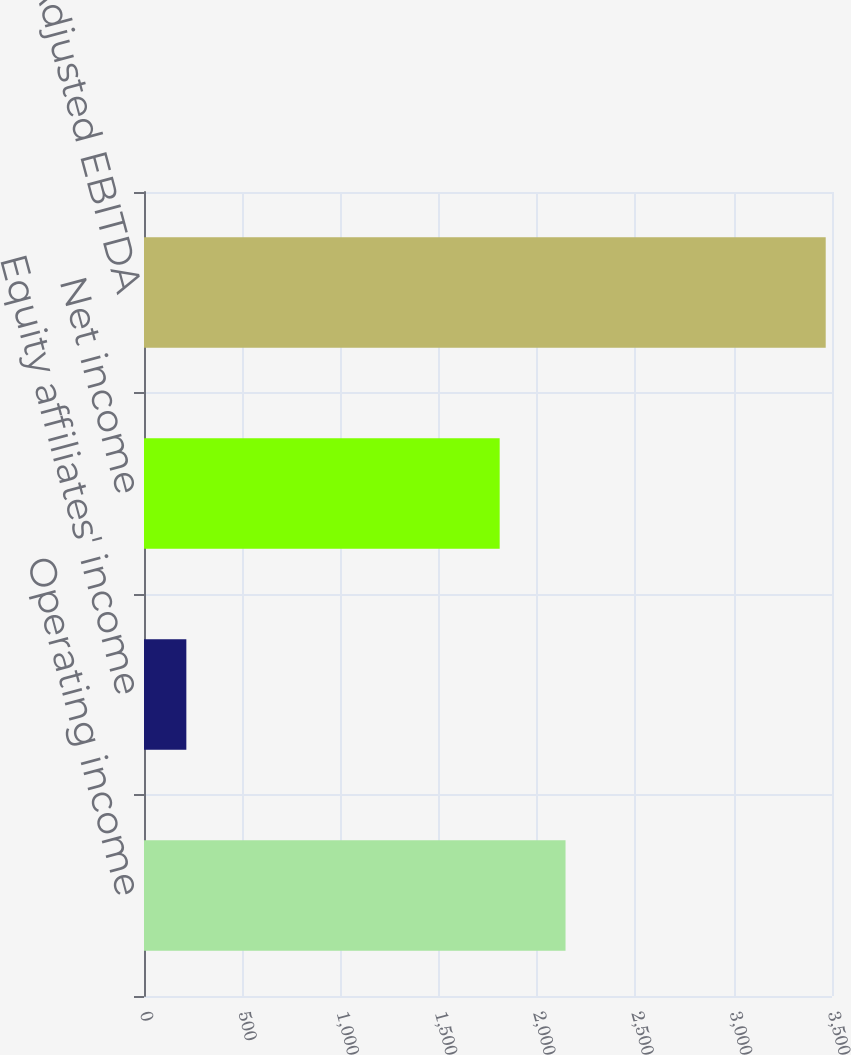Convert chart. <chart><loc_0><loc_0><loc_500><loc_500><bar_chart><fcel>Operating income<fcel>Equity affiliates' income<fcel>Net income<fcel>Adjusted EBITDA<nl><fcel>2144.4<fcel>215.4<fcel>1809.4<fcel>3468<nl></chart> 